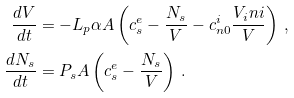Convert formula to latex. <formula><loc_0><loc_0><loc_500><loc_500>\frac { d V } { d t } & = - L _ { p } \alpha A \left ( c _ { s } ^ { e } - \frac { N _ { s } } { V } - c _ { n 0 } ^ { i } \frac { V _ { i } n i } { V } \right ) \, , \\ \frac { d N _ { s } } { d t } & = P _ { s } A \left ( c _ { s } ^ { e } - \frac { N _ { s } } { V } \right ) \, .</formula> 